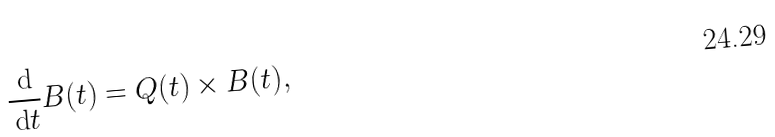<formula> <loc_0><loc_0><loc_500><loc_500>\frac { \, \text {d} } { \, \text {d} t } B ( t ) = Q ( t ) \times B ( t ) ,</formula> 